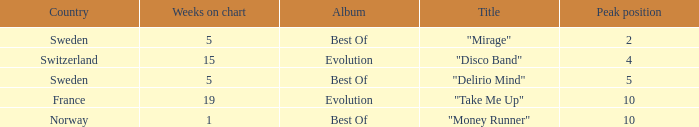Could you parse the entire table as a dict? {'header': ['Country', 'Weeks on chart', 'Album', 'Title', 'Peak position'], 'rows': [['Sweden', '5', 'Best Of', '"Mirage"', '2'], ['Switzerland', '15', 'Evolution', '"Disco Band"', '4'], ['Sweden', '5', 'Best Of', '"Delirio Mind"', '5'], ['France', '19', 'Evolution', '"Take Me Up"', '10'], ['Norway', '1', 'Best Of', '"Money Runner"', '10']]} What is the title of the single with the peak position of 10 and weeks on chart is less than 19? "Money Runner". 